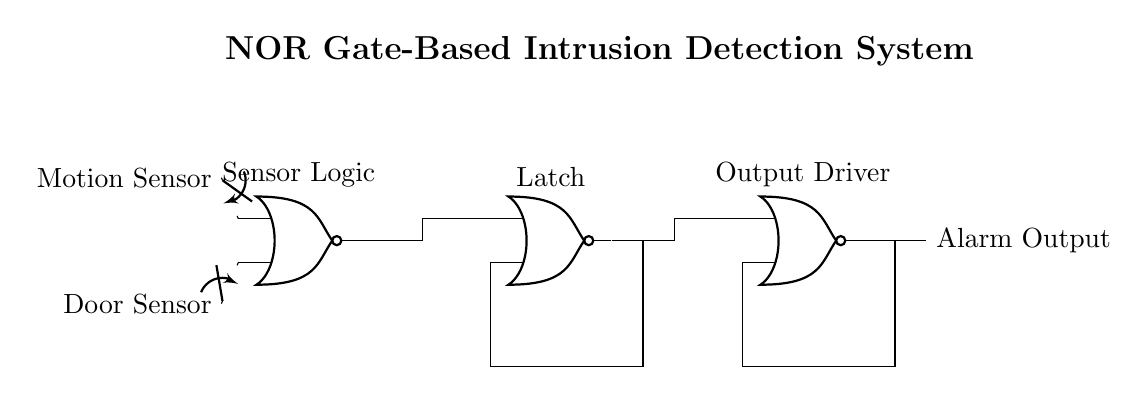What are the types of sensors used in this circuit? The diagram shows two sensors: a motion sensor and a door sensor, both connected to the NOR gate inputs.
Answer: Motion sensor and door sensor How many NOR gates are present in the circuit? The circuit diagram contains three NOR gates, each labeled at the top of the gates.
Answer: Three What is the output of the circuit? The output of the circuit is labeled "Alarm Output," indicating it activates an alarm when triggered.
Answer: Alarm Output Explain the feedback mechanism in this circuit. The circuit includes feedback loops from the outputs of NOR gates two and three back to their inputs, allowing the system to maintain its state once triggered, creating a latching effect.
Answer: Feedback loops for latching What is the function of the latch in the circuit? The latch (NOR gate 2) holds the state of the output signal based on input activations, maintaining alarm activation even if inputs become inactive, demonstrating memory in a logical circuit.
Answer: Holds the alarm state How does the motion sensor affect the overall system? The motion sensor, when activated, sends an input signal to the first NOR gate, influencing the output to trigger the alarm if either sensor is active, showcasing its role in intrusion detection.
Answer: Triggers the alarm 